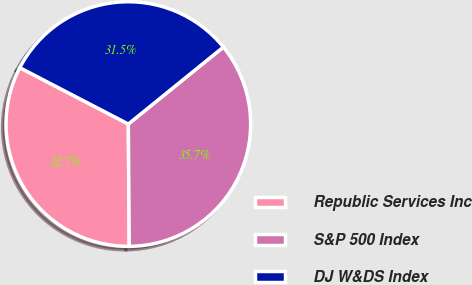Convert chart to OTSL. <chart><loc_0><loc_0><loc_500><loc_500><pie_chart><fcel>Republic Services Inc<fcel>S&P 500 Index<fcel>DJ W&DS Index<nl><fcel>32.74%<fcel>35.72%<fcel>31.54%<nl></chart> 